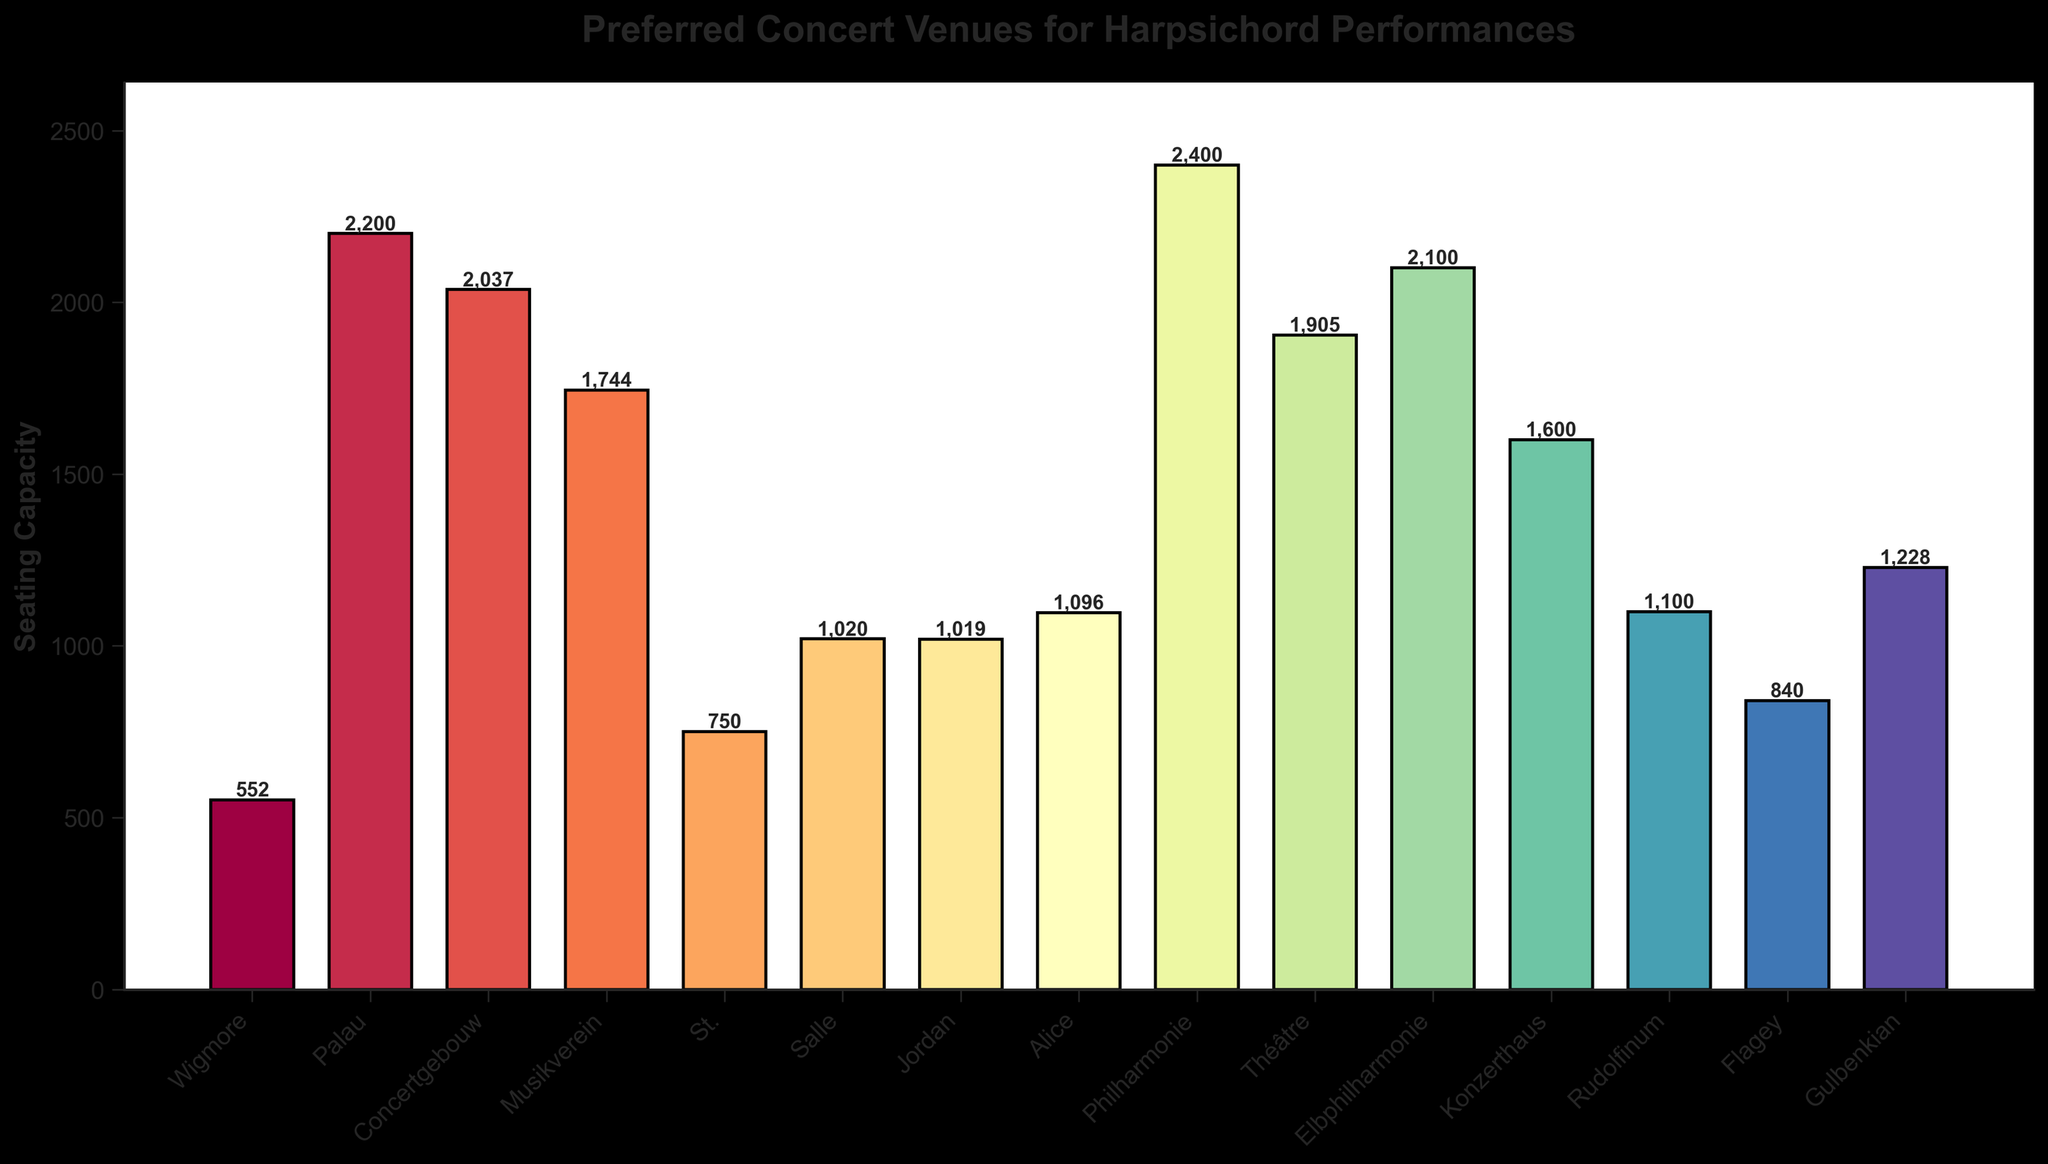Which venue has the highest seating capacity? The highest bar represents the Philharmonie de Paris.
Answer: Philharmonie de Paris Which venue has the lowest seating capacity? The shortest bar represents Wigmore Hall London.
Answer: Wigmore Hall London What is the difference in seating capacity between the Philharmonie de Paris and Wigmore Hall London? Philharmonie de Paris has a seating capacity of 2400, and Wigmore Hall London has 552. Subtract 552 from 2400: 2400 - 552 = 1848.
Answer: 1848 Which venues have a seating capacity greater than 2000? The bars that reach above 2000 represent Palau de la Música Catalana Barcelona, Philharmonie de Paris, Elbphilharmonie Hamburg, and Concertgebouw Amsterdam.
Answer: Palau de la Música Catalana Barcelona, Philharmonie de Paris, Elbphilharmonie Hamburg, Concertgebouw Amsterdam What is the average seating capacity of the venues in Paris? The seating capacities for Paris are 1020 (Salle Gaveau), 1905 (Théâtre des Champs-Élysées), and 2400 (Philharmonie de Paris). Calculate the average: (1020 + 1905 + 2400) / 3 = 5325 / 3 = 1775.
Answer: 1775 Which venue's bar is closest to the average seating capacity of all the venues? First, calculate the average capacity: (552 + 2200 + 2037 + 1744 + 750 + 1020 + 1019 + 1096 + 2400 + 1905 + 2100 + 1600 + 1100 + 840 + 1228) / 15 = 19091 / 15 ≈ 1273. Closest bar to 1273 is Gulbenkian Foundation Lisbon with 1228.
Answer: Gulbenkian Foundation Lisbon How many venues have a seating capacity between 1000 and 2000? Bars in this range are Salle Gaveau Paris (1020), Jordan Hall Boston (1019), Alice Tully Hall New York (1096), Rudolfinum Prague (1100), Théâtre des Champs-Élysées Paris (1905), Konzerthaus Berlin (1600), Gulbenkian Foundation Lisbon (1228). Count these venues: 7.
Answer: 7 Which venue in London has the highest seating capacity? Compare the seating capacities of the two London venues, Wigmore Hall London (552) and St. Martin-in-the-Fields London (750); St. Martin-in-the-Fields London has the highest.
Answer: St. Martin-in-the-Fields London What is the combined seating capacity of all venues in New York and Boston? Add the capacities for Alice Tully Hall New York (1096) and Jordan Hall Boston (1019): 1096 + 1019 = 2115.
Answer: 2115 